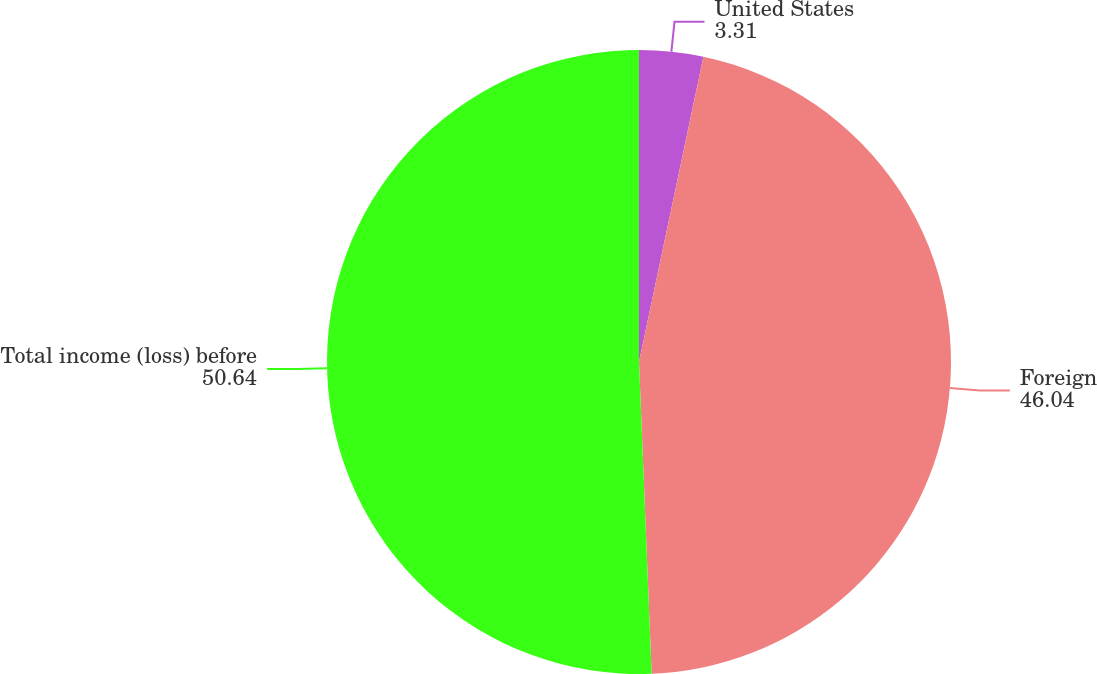Convert chart. <chart><loc_0><loc_0><loc_500><loc_500><pie_chart><fcel>United States<fcel>Foreign<fcel>Total income (loss) before<nl><fcel>3.31%<fcel>46.04%<fcel>50.64%<nl></chart> 